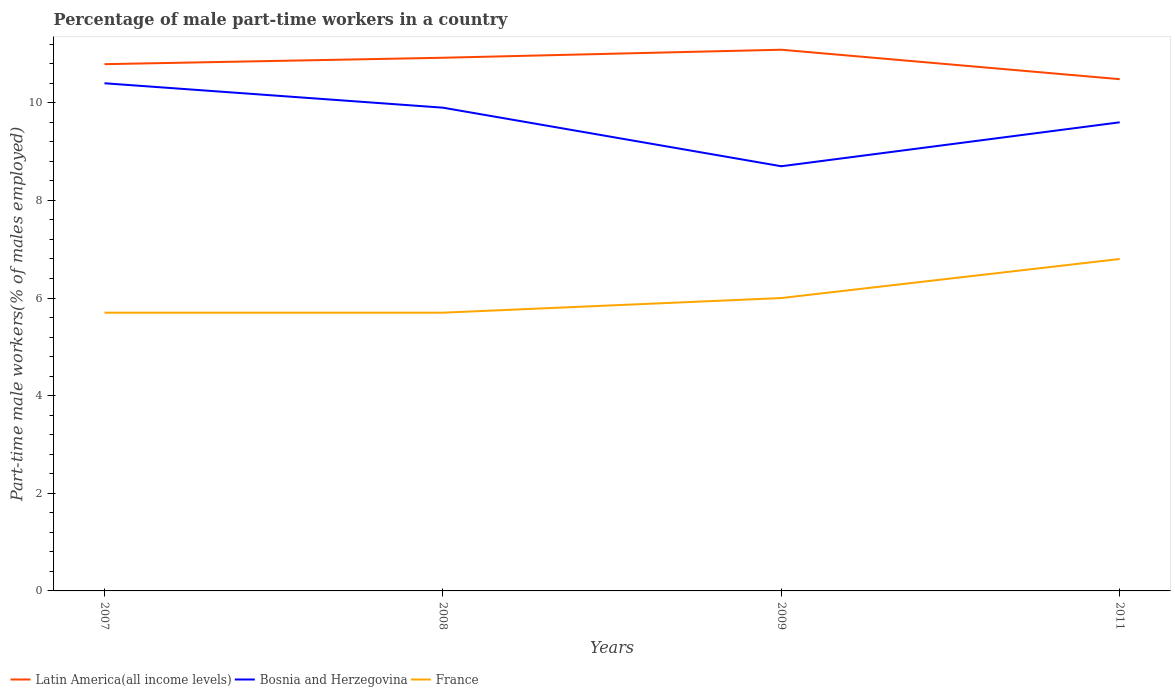Across all years, what is the maximum percentage of male part-time workers in Latin America(all income levels)?
Make the answer very short. 10.48. What is the total percentage of male part-time workers in France in the graph?
Offer a very short reply. -0.3. What is the difference between the highest and the second highest percentage of male part-time workers in Bosnia and Herzegovina?
Offer a terse response. 1.7. Is the percentage of male part-time workers in Latin America(all income levels) strictly greater than the percentage of male part-time workers in Bosnia and Herzegovina over the years?
Provide a short and direct response. No. How many lines are there?
Provide a succinct answer. 3. Does the graph contain any zero values?
Offer a very short reply. No. Where does the legend appear in the graph?
Provide a short and direct response. Bottom left. How many legend labels are there?
Provide a succinct answer. 3. How are the legend labels stacked?
Provide a short and direct response. Horizontal. What is the title of the graph?
Provide a succinct answer. Percentage of male part-time workers in a country. Does "Morocco" appear as one of the legend labels in the graph?
Offer a terse response. No. What is the label or title of the X-axis?
Your answer should be very brief. Years. What is the label or title of the Y-axis?
Give a very brief answer. Part-time male workers(% of males employed). What is the Part-time male workers(% of males employed) in Latin America(all income levels) in 2007?
Give a very brief answer. 10.79. What is the Part-time male workers(% of males employed) of Bosnia and Herzegovina in 2007?
Ensure brevity in your answer.  10.4. What is the Part-time male workers(% of males employed) of France in 2007?
Offer a terse response. 5.7. What is the Part-time male workers(% of males employed) of Latin America(all income levels) in 2008?
Keep it short and to the point. 10.92. What is the Part-time male workers(% of males employed) of Bosnia and Herzegovina in 2008?
Offer a terse response. 9.9. What is the Part-time male workers(% of males employed) of France in 2008?
Offer a terse response. 5.7. What is the Part-time male workers(% of males employed) of Latin America(all income levels) in 2009?
Provide a short and direct response. 11.09. What is the Part-time male workers(% of males employed) of Bosnia and Herzegovina in 2009?
Keep it short and to the point. 8.7. What is the Part-time male workers(% of males employed) of France in 2009?
Keep it short and to the point. 6. What is the Part-time male workers(% of males employed) of Latin America(all income levels) in 2011?
Your response must be concise. 10.48. What is the Part-time male workers(% of males employed) in Bosnia and Herzegovina in 2011?
Provide a short and direct response. 9.6. What is the Part-time male workers(% of males employed) in France in 2011?
Your answer should be very brief. 6.8. Across all years, what is the maximum Part-time male workers(% of males employed) in Latin America(all income levels)?
Provide a short and direct response. 11.09. Across all years, what is the maximum Part-time male workers(% of males employed) in Bosnia and Herzegovina?
Offer a very short reply. 10.4. Across all years, what is the maximum Part-time male workers(% of males employed) of France?
Give a very brief answer. 6.8. Across all years, what is the minimum Part-time male workers(% of males employed) of Latin America(all income levels)?
Give a very brief answer. 10.48. Across all years, what is the minimum Part-time male workers(% of males employed) of Bosnia and Herzegovina?
Provide a succinct answer. 8.7. Across all years, what is the minimum Part-time male workers(% of males employed) in France?
Your answer should be compact. 5.7. What is the total Part-time male workers(% of males employed) in Latin America(all income levels) in the graph?
Ensure brevity in your answer.  43.28. What is the total Part-time male workers(% of males employed) in Bosnia and Herzegovina in the graph?
Your answer should be compact. 38.6. What is the total Part-time male workers(% of males employed) in France in the graph?
Ensure brevity in your answer.  24.2. What is the difference between the Part-time male workers(% of males employed) in Latin America(all income levels) in 2007 and that in 2008?
Ensure brevity in your answer.  -0.13. What is the difference between the Part-time male workers(% of males employed) in Bosnia and Herzegovina in 2007 and that in 2008?
Ensure brevity in your answer.  0.5. What is the difference between the Part-time male workers(% of males employed) of Latin America(all income levels) in 2007 and that in 2009?
Your answer should be very brief. -0.3. What is the difference between the Part-time male workers(% of males employed) in France in 2007 and that in 2009?
Your response must be concise. -0.3. What is the difference between the Part-time male workers(% of males employed) in Latin America(all income levels) in 2007 and that in 2011?
Provide a short and direct response. 0.31. What is the difference between the Part-time male workers(% of males employed) in Latin America(all income levels) in 2008 and that in 2009?
Offer a terse response. -0.16. What is the difference between the Part-time male workers(% of males employed) in Bosnia and Herzegovina in 2008 and that in 2009?
Make the answer very short. 1.2. What is the difference between the Part-time male workers(% of males employed) of Latin America(all income levels) in 2008 and that in 2011?
Provide a succinct answer. 0.44. What is the difference between the Part-time male workers(% of males employed) in Bosnia and Herzegovina in 2008 and that in 2011?
Keep it short and to the point. 0.3. What is the difference between the Part-time male workers(% of males employed) of France in 2008 and that in 2011?
Offer a very short reply. -1.1. What is the difference between the Part-time male workers(% of males employed) of Latin America(all income levels) in 2009 and that in 2011?
Offer a very short reply. 0.6. What is the difference between the Part-time male workers(% of males employed) of Latin America(all income levels) in 2007 and the Part-time male workers(% of males employed) of Bosnia and Herzegovina in 2008?
Keep it short and to the point. 0.89. What is the difference between the Part-time male workers(% of males employed) of Latin America(all income levels) in 2007 and the Part-time male workers(% of males employed) of France in 2008?
Keep it short and to the point. 5.09. What is the difference between the Part-time male workers(% of males employed) of Latin America(all income levels) in 2007 and the Part-time male workers(% of males employed) of Bosnia and Herzegovina in 2009?
Offer a very short reply. 2.09. What is the difference between the Part-time male workers(% of males employed) of Latin America(all income levels) in 2007 and the Part-time male workers(% of males employed) of France in 2009?
Your answer should be very brief. 4.79. What is the difference between the Part-time male workers(% of males employed) in Latin America(all income levels) in 2007 and the Part-time male workers(% of males employed) in Bosnia and Herzegovina in 2011?
Offer a very short reply. 1.19. What is the difference between the Part-time male workers(% of males employed) of Latin America(all income levels) in 2007 and the Part-time male workers(% of males employed) of France in 2011?
Provide a short and direct response. 3.99. What is the difference between the Part-time male workers(% of males employed) of Bosnia and Herzegovina in 2007 and the Part-time male workers(% of males employed) of France in 2011?
Your answer should be very brief. 3.6. What is the difference between the Part-time male workers(% of males employed) of Latin America(all income levels) in 2008 and the Part-time male workers(% of males employed) of Bosnia and Herzegovina in 2009?
Offer a terse response. 2.22. What is the difference between the Part-time male workers(% of males employed) in Latin America(all income levels) in 2008 and the Part-time male workers(% of males employed) in France in 2009?
Ensure brevity in your answer.  4.92. What is the difference between the Part-time male workers(% of males employed) of Bosnia and Herzegovina in 2008 and the Part-time male workers(% of males employed) of France in 2009?
Offer a very short reply. 3.9. What is the difference between the Part-time male workers(% of males employed) of Latin America(all income levels) in 2008 and the Part-time male workers(% of males employed) of Bosnia and Herzegovina in 2011?
Make the answer very short. 1.32. What is the difference between the Part-time male workers(% of males employed) in Latin America(all income levels) in 2008 and the Part-time male workers(% of males employed) in France in 2011?
Keep it short and to the point. 4.12. What is the difference between the Part-time male workers(% of males employed) in Latin America(all income levels) in 2009 and the Part-time male workers(% of males employed) in Bosnia and Herzegovina in 2011?
Your answer should be very brief. 1.49. What is the difference between the Part-time male workers(% of males employed) in Latin America(all income levels) in 2009 and the Part-time male workers(% of males employed) in France in 2011?
Ensure brevity in your answer.  4.29. What is the difference between the Part-time male workers(% of males employed) in Bosnia and Herzegovina in 2009 and the Part-time male workers(% of males employed) in France in 2011?
Your answer should be compact. 1.9. What is the average Part-time male workers(% of males employed) of Latin America(all income levels) per year?
Your answer should be compact. 10.82. What is the average Part-time male workers(% of males employed) of Bosnia and Herzegovina per year?
Provide a short and direct response. 9.65. What is the average Part-time male workers(% of males employed) in France per year?
Give a very brief answer. 6.05. In the year 2007, what is the difference between the Part-time male workers(% of males employed) in Latin America(all income levels) and Part-time male workers(% of males employed) in Bosnia and Herzegovina?
Your answer should be compact. 0.39. In the year 2007, what is the difference between the Part-time male workers(% of males employed) of Latin America(all income levels) and Part-time male workers(% of males employed) of France?
Offer a terse response. 5.09. In the year 2007, what is the difference between the Part-time male workers(% of males employed) in Bosnia and Herzegovina and Part-time male workers(% of males employed) in France?
Provide a succinct answer. 4.7. In the year 2008, what is the difference between the Part-time male workers(% of males employed) of Latin America(all income levels) and Part-time male workers(% of males employed) of Bosnia and Herzegovina?
Make the answer very short. 1.02. In the year 2008, what is the difference between the Part-time male workers(% of males employed) of Latin America(all income levels) and Part-time male workers(% of males employed) of France?
Ensure brevity in your answer.  5.22. In the year 2008, what is the difference between the Part-time male workers(% of males employed) of Bosnia and Herzegovina and Part-time male workers(% of males employed) of France?
Offer a very short reply. 4.2. In the year 2009, what is the difference between the Part-time male workers(% of males employed) of Latin America(all income levels) and Part-time male workers(% of males employed) of Bosnia and Herzegovina?
Your answer should be compact. 2.39. In the year 2009, what is the difference between the Part-time male workers(% of males employed) of Latin America(all income levels) and Part-time male workers(% of males employed) of France?
Offer a terse response. 5.09. In the year 2009, what is the difference between the Part-time male workers(% of males employed) of Bosnia and Herzegovina and Part-time male workers(% of males employed) of France?
Give a very brief answer. 2.7. In the year 2011, what is the difference between the Part-time male workers(% of males employed) of Latin America(all income levels) and Part-time male workers(% of males employed) of Bosnia and Herzegovina?
Your answer should be compact. 0.88. In the year 2011, what is the difference between the Part-time male workers(% of males employed) in Latin America(all income levels) and Part-time male workers(% of males employed) in France?
Offer a terse response. 3.68. In the year 2011, what is the difference between the Part-time male workers(% of males employed) in Bosnia and Herzegovina and Part-time male workers(% of males employed) in France?
Your response must be concise. 2.8. What is the ratio of the Part-time male workers(% of males employed) in Bosnia and Herzegovina in 2007 to that in 2008?
Keep it short and to the point. 1.05. What is the ratio of the Part-time male workers(% of males employed) in Latin America(all income levels) in 2007 to that in 2009?
Your response must be concise. 0.97. What is the ratio of the Part-time male workers(% of males employed) in Bosnia and Herzegovina in 2007 to that in 2009?
Offer a very short reply. 1.2. What is the ratio of the Part-time male workers(% of males employed) of Latin America(all income levels) in 2007 to that in 2011?
Give a very brief answer. 1.03. What is the ratio of the Part-time male workers(% of males employed) of France in 2007 to that in 2011?
Provide a short and direct response. 0.84. What is the ratio of the Part-time male workers(% of males employed) of Latin America(all income levels) in 2008 to that in 2009?
Make the answer very short. 0.99. What is the ratio of the Part-time male workers(% of males employed) in Bosnia and Herzegovina in 2008 to that in 2009?
Keep it short and to the point. 1.14. What is the ratio of the Part-time male workers(% of males employed) of Latin America(all income levels) in 2008 to that in 2011?
Provide a short and direct response. 1.04. What is the ratio of the Part-time male workers(% of males employed) of Bosnia and Herzegovina in 2008 to that in 2011?
Your answer should be very brief. 1.03. What is the ratio of the Part-time male workers(% of males employed) in France in 2008 to that in 2011?
Offer a terse response. 0.84. What is the ratio of the Part-time male workers(% of males employed) in Latin America(all income levels) in 2009 to that in 2011?
Keep it short and to the point. 1.06. What is the ratio of the Part-time male workers(% of males employed) of Bosnia and Herzegovina in 2009 to that in 2011?
Provide a short and direct response. 0.91. What is the ratio of the Part-time male workers(% of males employed) of France in 2009 to that in 2011?
Offer a very short reply. 0.88. What is the difference between the highest and the second highest Part-time male workers(% of males employed) in Latin America(all income levels)?
Your answer should be compact. 0.16. What is the difference between the highest and the second highest Part-time male workers(% of males employed) in France?
Give a very brief answer. 0.8. What is the difference between the highest and the lowest Part-time male workers(% of males employed) of Latin America(all income levels)?
Offer a very short reply. 0.6. What is the difference between the highest and the lowest Part-time male workers(% of males employed) of France?
Provide a succinct answer. 1.1. 